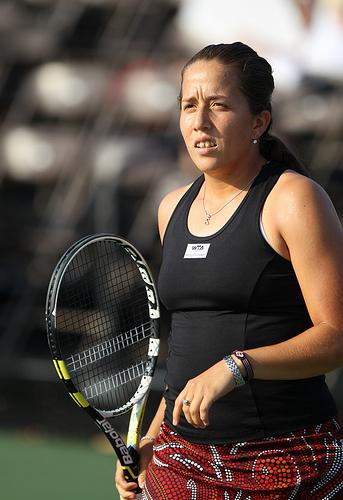Question: who is standing in this photo?
Choices:
A. A man.
B. A woman.
C. A girl.
D. A boy.
Answer with the letter. Answer: B Question: when will the woman leave the court?
Choices:
A. After she has finished playing tennis.
B. In the middle of the game.
C. In 24 hours.
D. In 48 hours.
Answer with the letter. Answer: A Question: where is this photo taken?
Choices:
A. On a basketball court.
B. On a squash court.
C. On a volleyball court.
D. On a tennis court.
Answer with the letter. Answer: D Question: what is the woman holding?
Choices:
A. A tennis racket.
B. A lacrosse stick.
C. A hockey stick.
D. A baseball bat.
Answer with the letter. Answer: A 